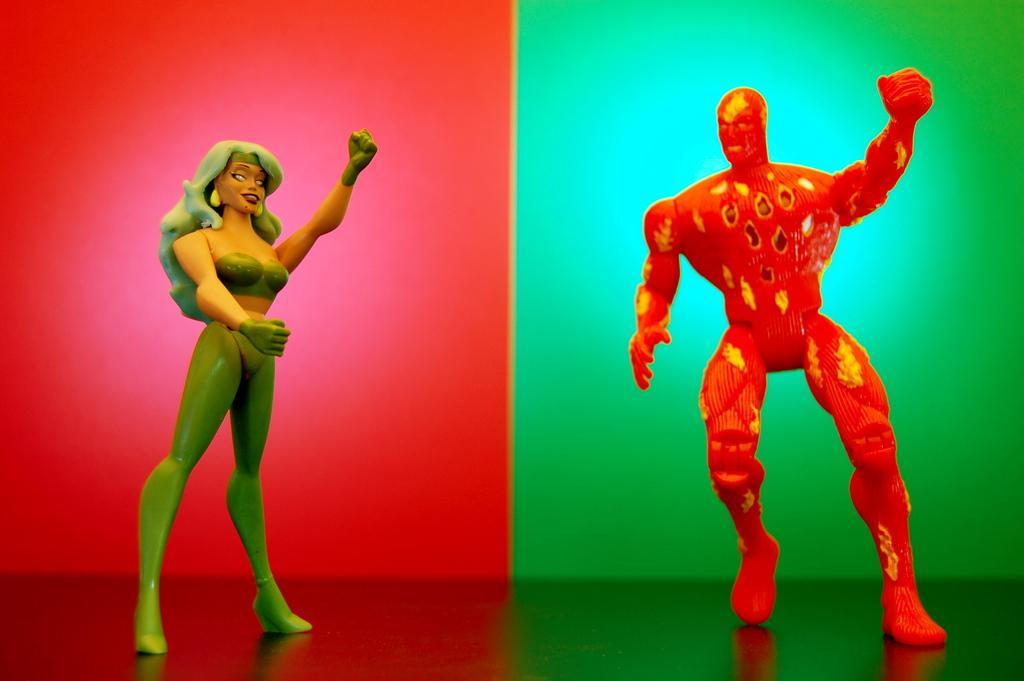In one or two sentences, can you explain what this image depicts? In this picture we can see toys are there. In the background of the image we can see red and green color are there. At the bottom of the image we can see a floor. 